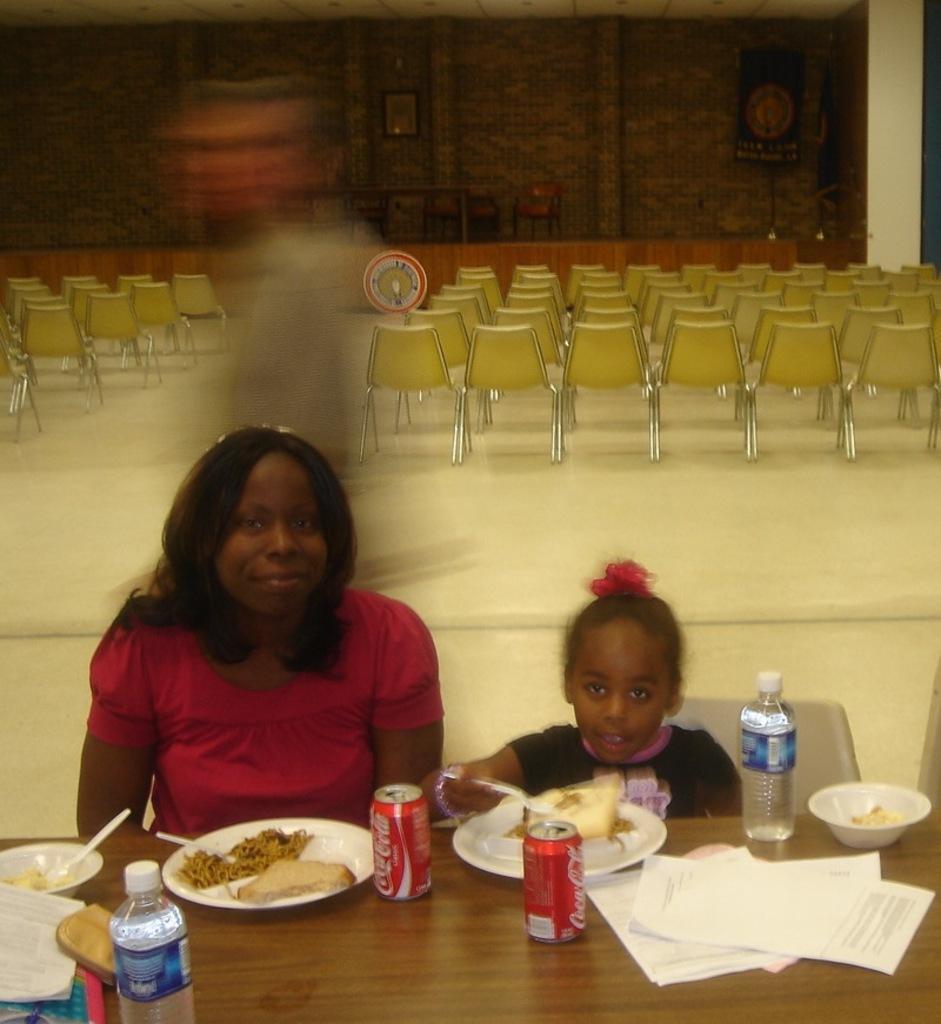Could you give a brief overview of what you see in this image? In this picture there is a woman and a girl sitting on the chair. There is a bottle, bowl, food in the plate, spoon , papers, coke tins on the table. There are many chairs at the background. 